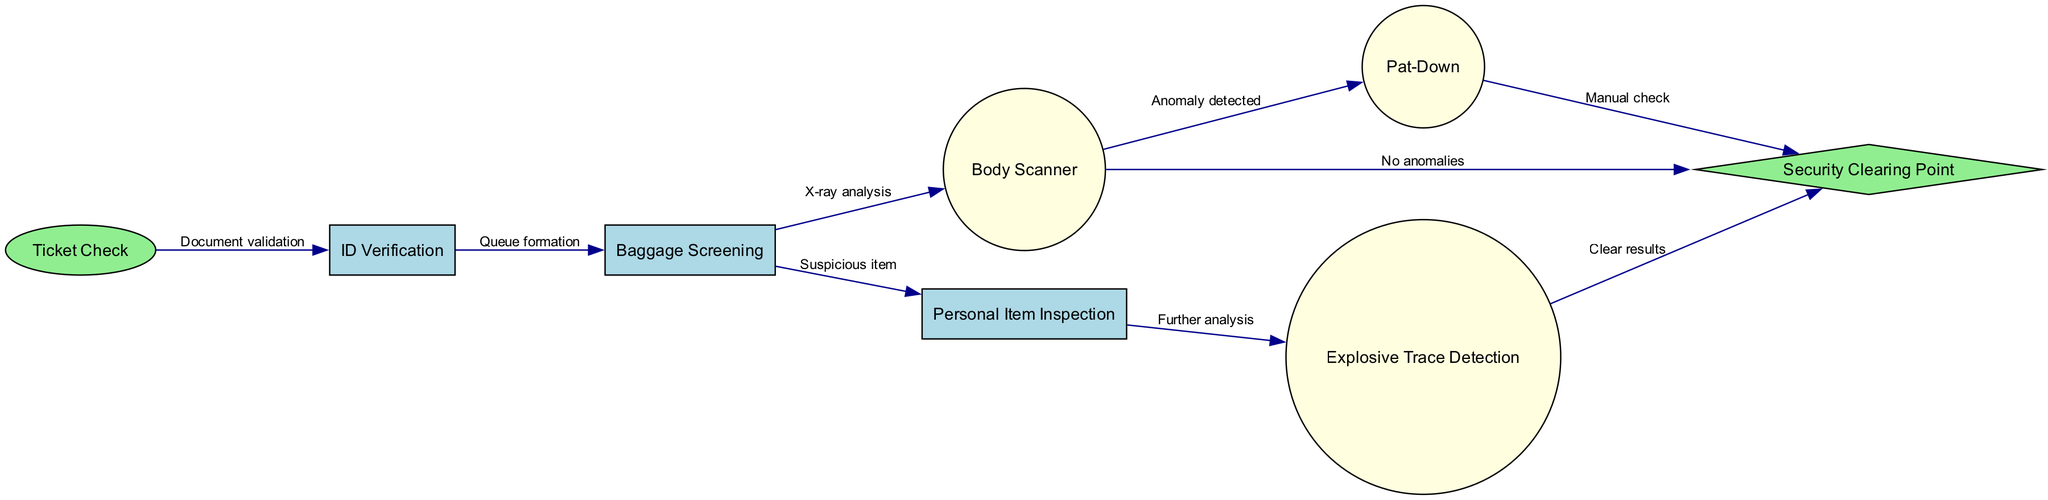What is the first step in the passenger flow? The first step in the diagram is "Ticket Check," where passengers present their tickets for validation before proceeding to the next checkpoint.
Answer: Ticket Check How many nodes are there in total? The diagram contains eight nodes that represent various steps in the airport security process, including "Ticket Check," "ID Verification," "Baggage Screening," "Body Scanner," "Pat-Down," "Personal Item Inspection," "Explosive Trace Detection," and "Security Clearing Point."
Answer: Eight What do you need to do after baggage screening if an anomaly is detected? If an anomaly is detected after the "Baggage Screening," the flow requires the passenger to undergo a "Pat-Down" for a manual check before proceeding to the "Security Clearing Point."
Answer: Pat-Down Which step follows ID verification? After completing "ID Verification," passengers move to "Baggage Screening" where their baggage is screened for any prohibited items or anomalies.
Answer: Baggage Screening What is the final destination point in the diagram? The final destination point in the diagram is the "Security Clearing Point," where passengers are either cleared or directed for further checks based on the previous steps.
Answer: Security Clearing Point What happens if a suspicious item is found during screening? If a suspicious item is identified during "Baggage Screening," it leads to "Personal Item Inspection," where the item undergoes further examination, and possibly explosive trace detection.
Answer: Personal Item Inspection If a passenger clears the body scanner with no anomalies, where do they go next? After clearing the body scanner with no anomalies indicated, the passenger goes directly to the "Security Clearing Point," concluding the security check.
Answer: Security Clearing Point What is required for further analysis of personal items? If personal items require further inspection after "Personal Item Inspection," they will undergo "Explosive Trace Detection" to determine if any hazardous materials are present.
Answer: Explosive Trace Detection 